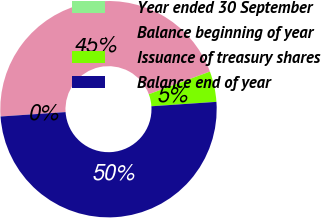Convert chart to OTSL. <chart><loc_0><loc_0><loc_500><loc_500><pie_chart><fcel>Year ended 30 September<fcel>Balance beginning of year<fcel>Issuance of treasury shares<fcel>Balance end of year<nl><fcel>0.0%<fcel>45.43%<fcel>4.57%<fcel>50.0%<nl></chart> 